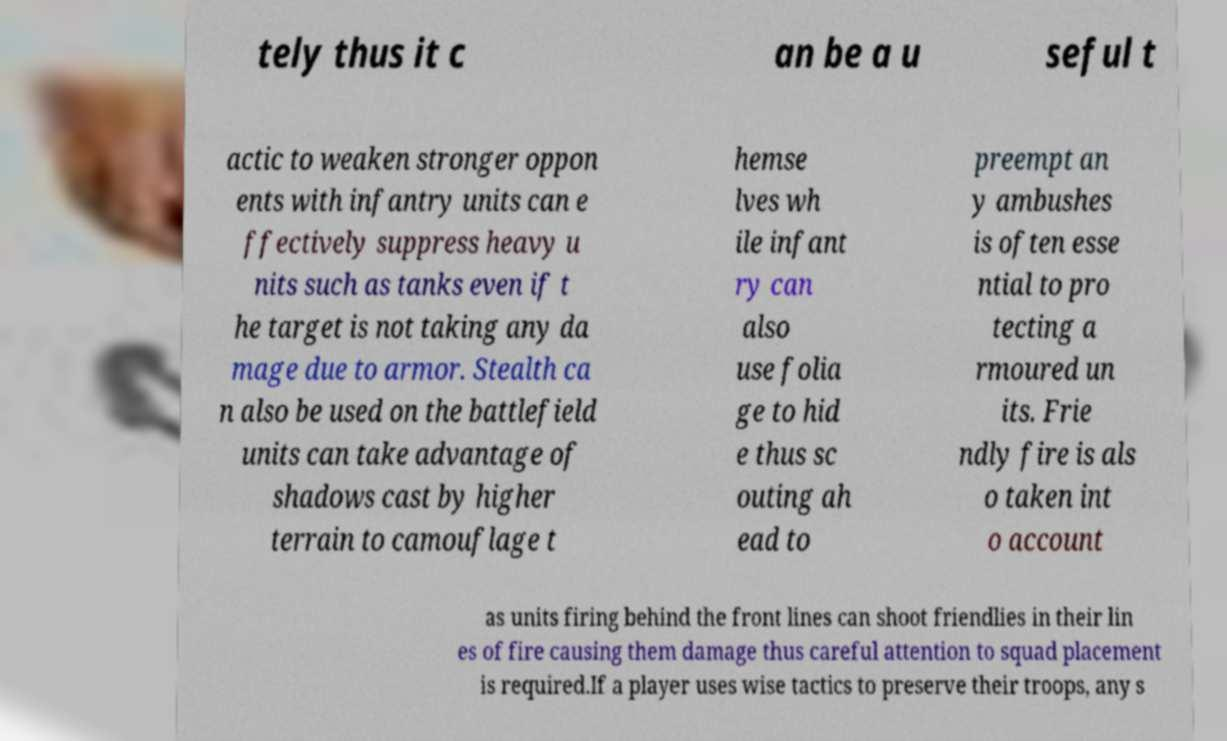There's text embedded in this image that I need extracted. Can you transcribe it verbatim? tely thus it c an be a u seful t actic to weaken stronger oppon ents with infantry units can e ffectively suppress heavy u nits such as tanks even if t he target is not taking any da mage due to armor. Stealth ca n also be used on the battlefield units can take advantage of shadows cast by higher terrain to camouflage t hemse lves wh ile infant ry can also use folia ge to hid e thus sc outing ah ead to preempt an y ambushes is often esse ntial to pro tecting a rmoured un its. Frie ndly fire is als o taken int o account as units firing behind the front lines can shoot friendlies in their lin es of fire causing them damage thus careful attention to squad placement is required.If a player uses wise tactics to preserve their troops, any s 